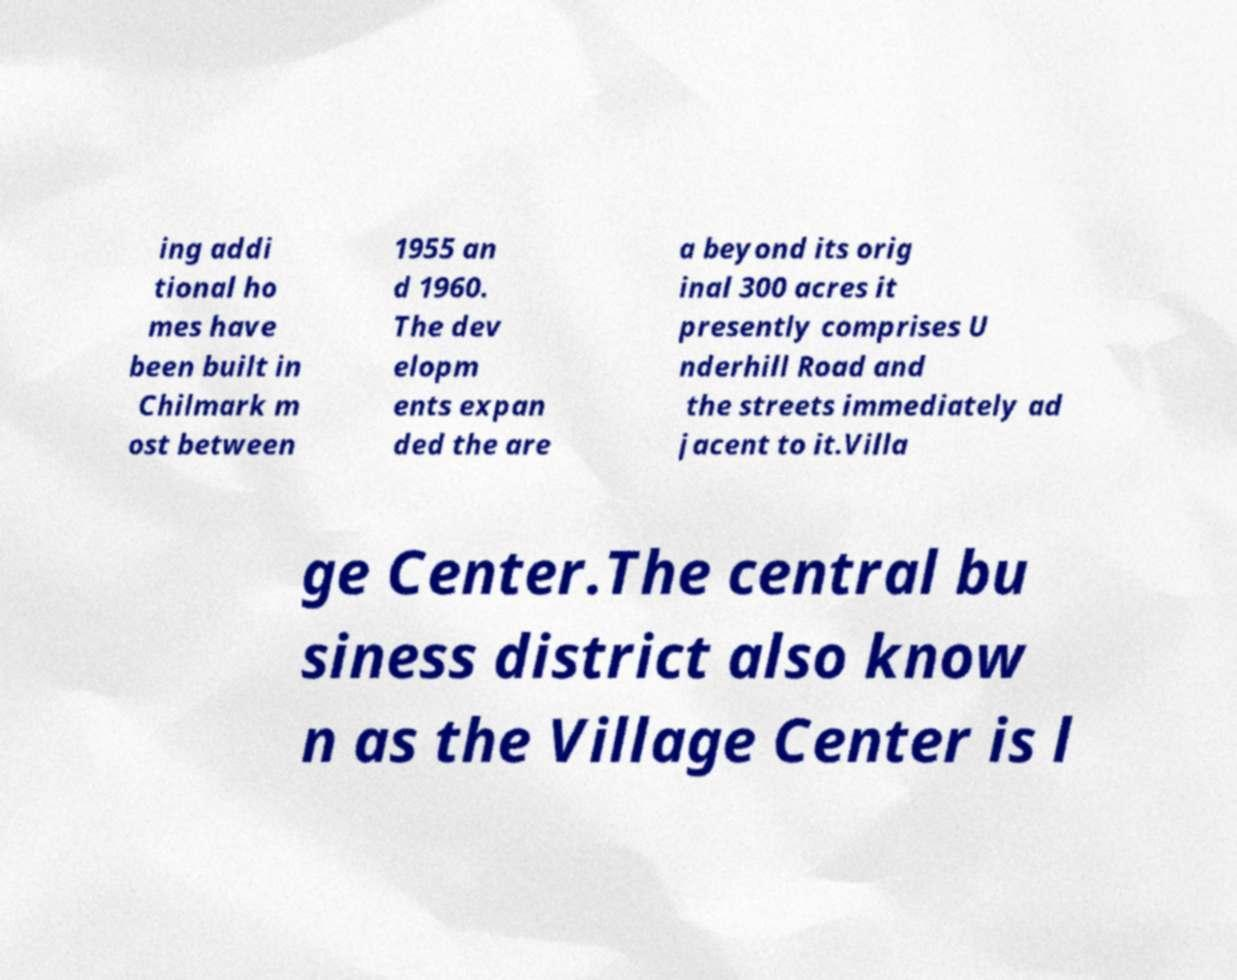Could you assist in decoding the text presented in this image and type it out clearly? ing addi tional ho mes have been built in Chilmark m ost between 1955 an d 1960. The dev elopm ents expan ded the are a beyond its orig inal 300 acres it presently comprises U nderhill Road and the streets immediately ad jacent to it.Villa ge Center.The central bu siness district also know n as the Village Center is l 